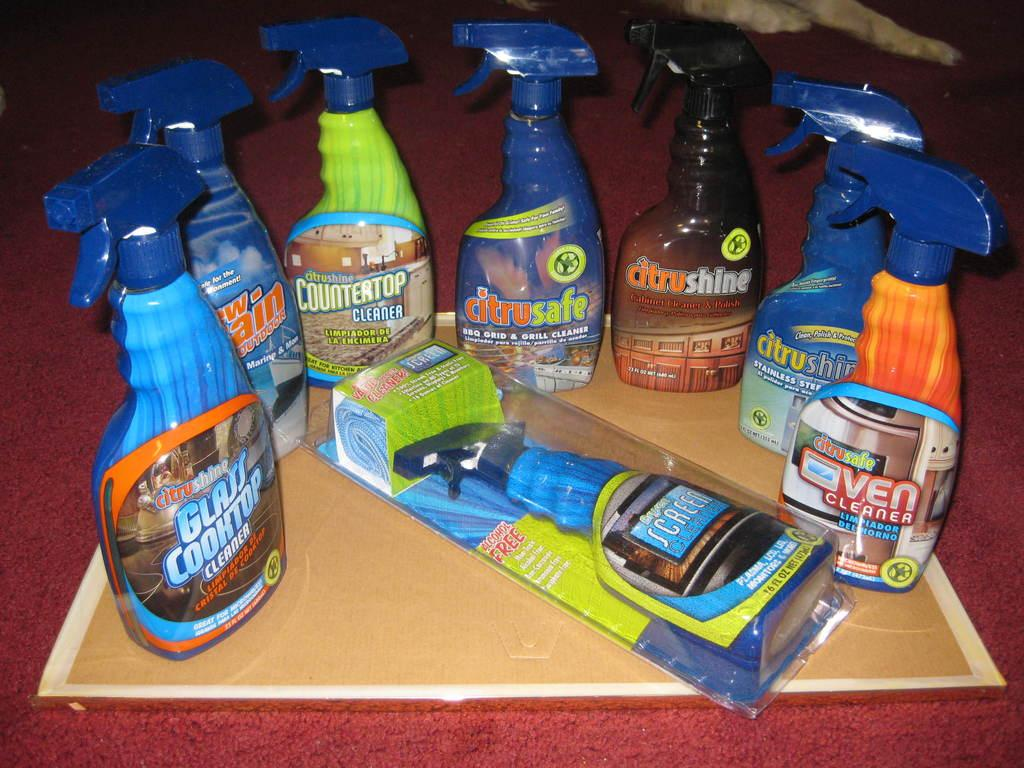<image>
Give a short and clear explanation of the subsequent image. Washing liquids on a table with one that says GLASS COOKTOP. 